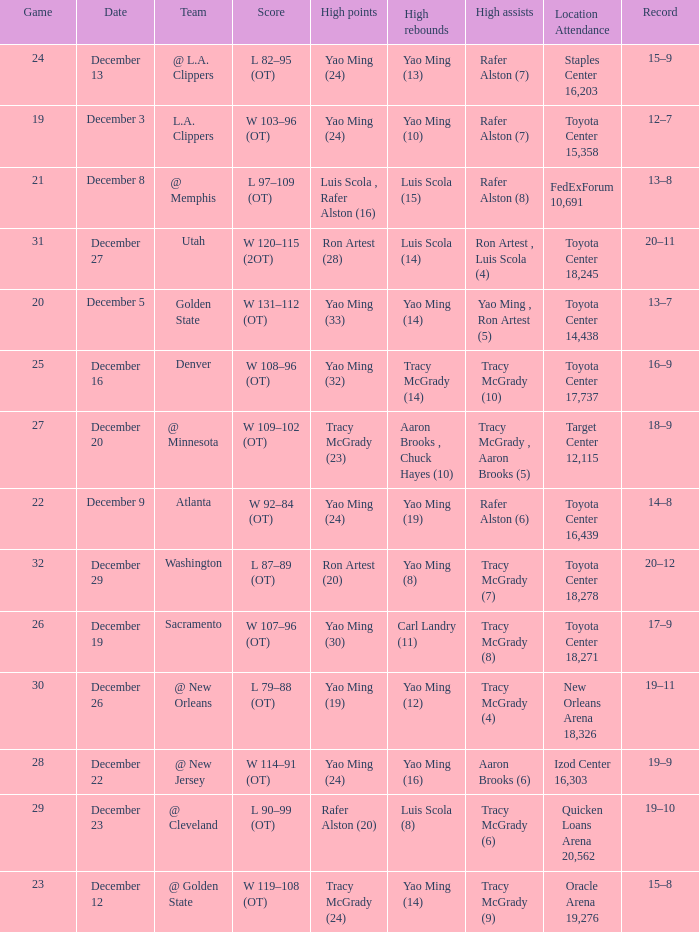When tracy mcgrady (8) is leading in assists what is the date? December 19. 